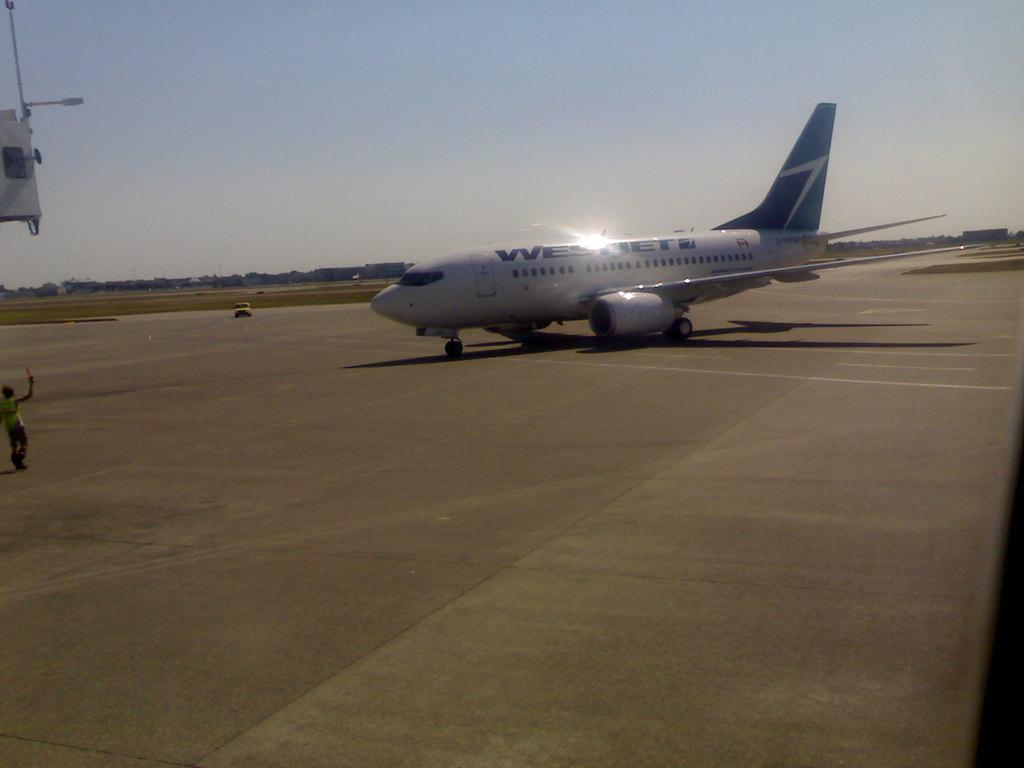Provide a one-sentence caption for the provided image. West Jet is displayed on the side of the passenger plane on the tarmac. 